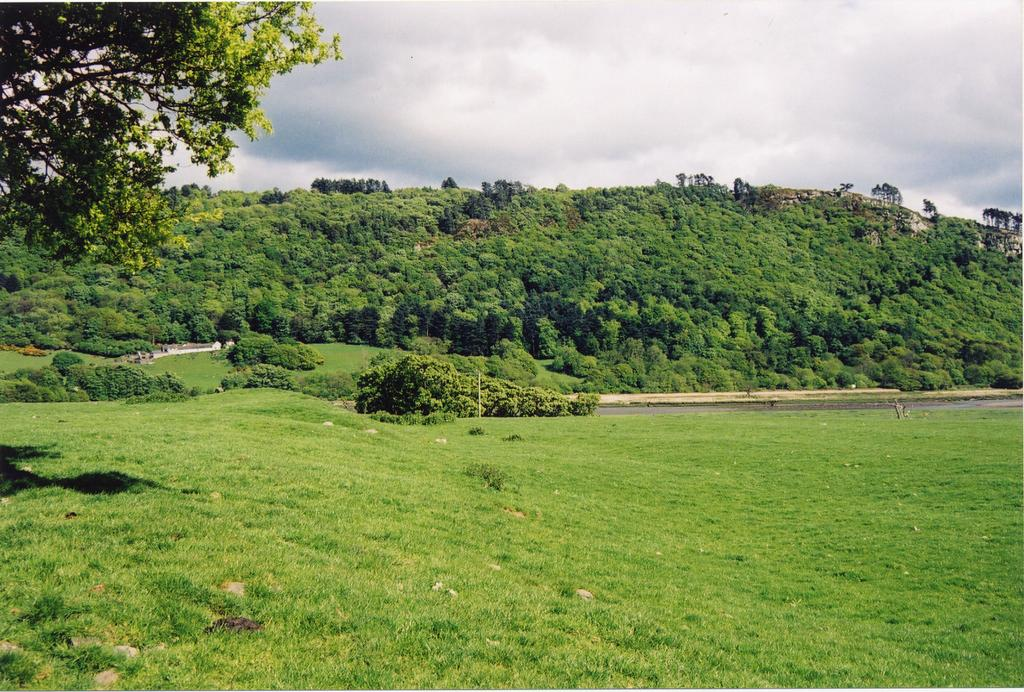What type of vegetation is predominant in the image? There is a lot of grass in the image. Are there any other types of vegetation besides grass? Yes, there are trees in the image. What type of rock is being used as a brake in the image? There is no rock or brake present in the image; it features grass and trees. 